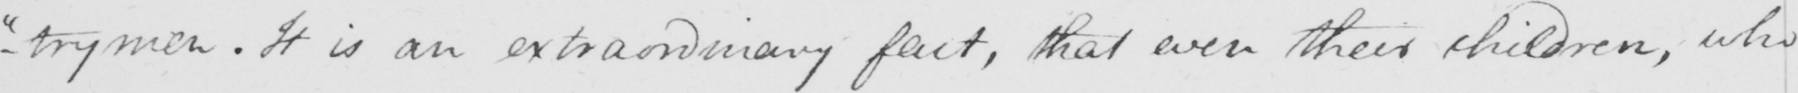What text is written in this handwritten line? -"trymen. "It is an extraordinary fact, that even their children, who 